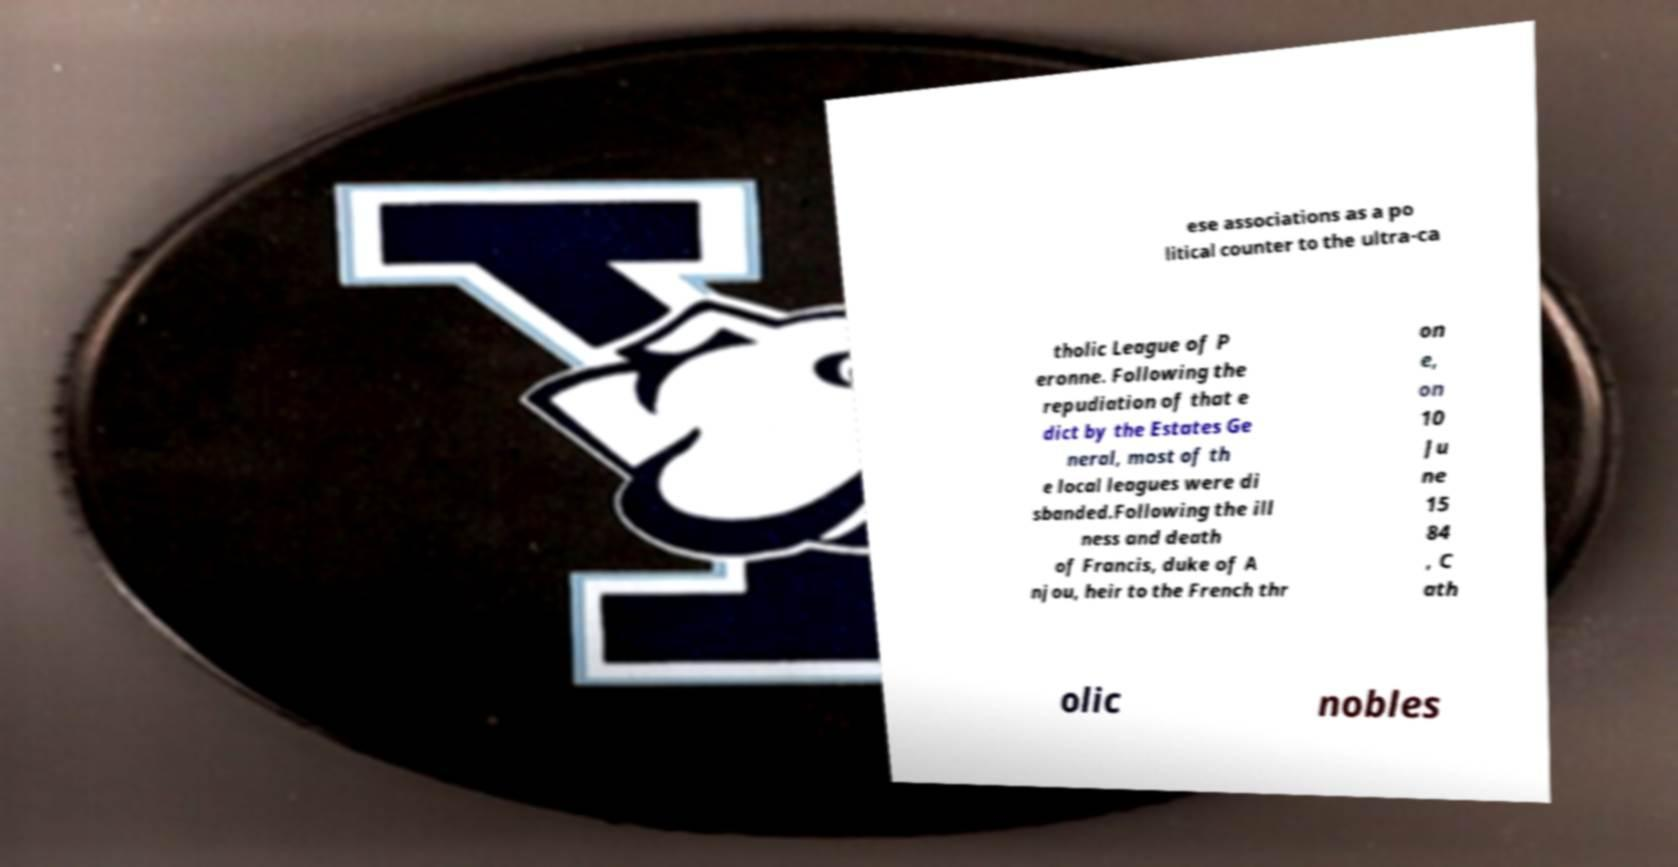Could you assist in decoding the text presented in this image and type it out clearly? ese associations as a po litical counter to the ultra-ca tholic League of P eronne. Following the repudiation of that e dict by the Estates Ge neral, most of th e local leagues were di sbanded.Following the ill ness and death of Francis, duke of A njou, heir to the French thr on e, on 10 Ju ne 15 84 , C ath olic nobles 